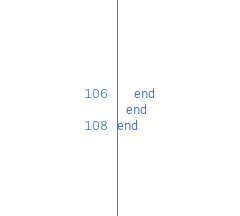<code> <loc_0><loc_0><loc_500><loc_500><_Crystal_>    end
  end
end
</code> 